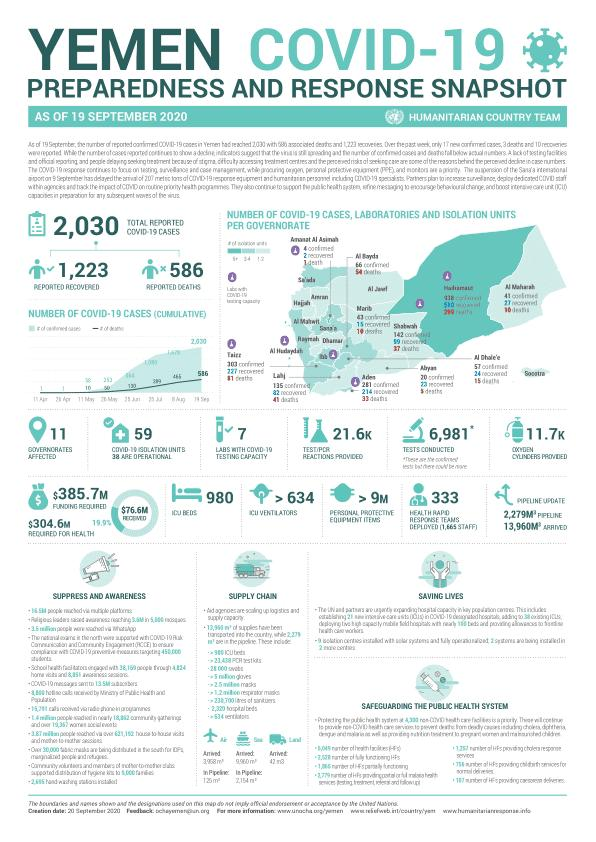Mention a couple of crucial points in this snapshot. There are 980 intensive care unit (ICU) beds. There have been 586 reported cases. A total of 1,223 items have been successfully recovered. There are currently 7 labs with the capacity to conduct COVID-19 tests. 